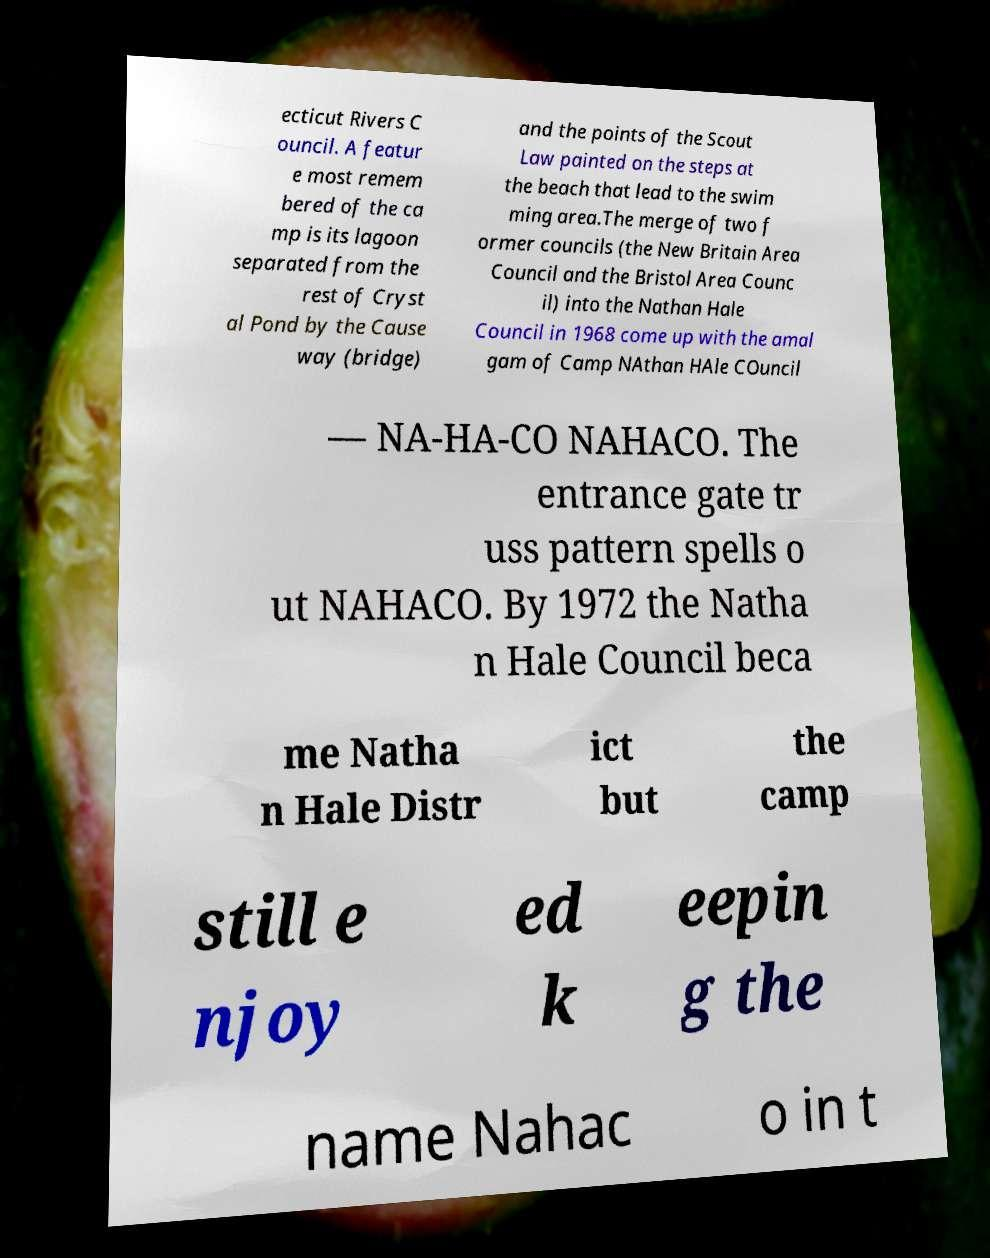I need the written content from this picture converted into text. Can you do that? ecticut Rivers C ouncil. A featur e most remem bered of the ca mp is its lagoon separated from the rest of Cryst al Pond by the Cause way (bridge) and the points of the Scout Law painted on the steps at the beach that lead to the swim ming area.The merge of two f ormer councils (the New Britain Area Council and the Bristol Area Counc il) into the Nathan Hale Council in 1968 come up with the amal gam of Camp NAthan HAle COuncil — NA-HA-CO NAHACO. The entrance gate tr uss pattern spells o ut NAHACO. By 1972 the Natha n Hale Council beca me Natha n Hale Distr ict but the camp still e njoy ed k eepin g the name Nahac o in t 